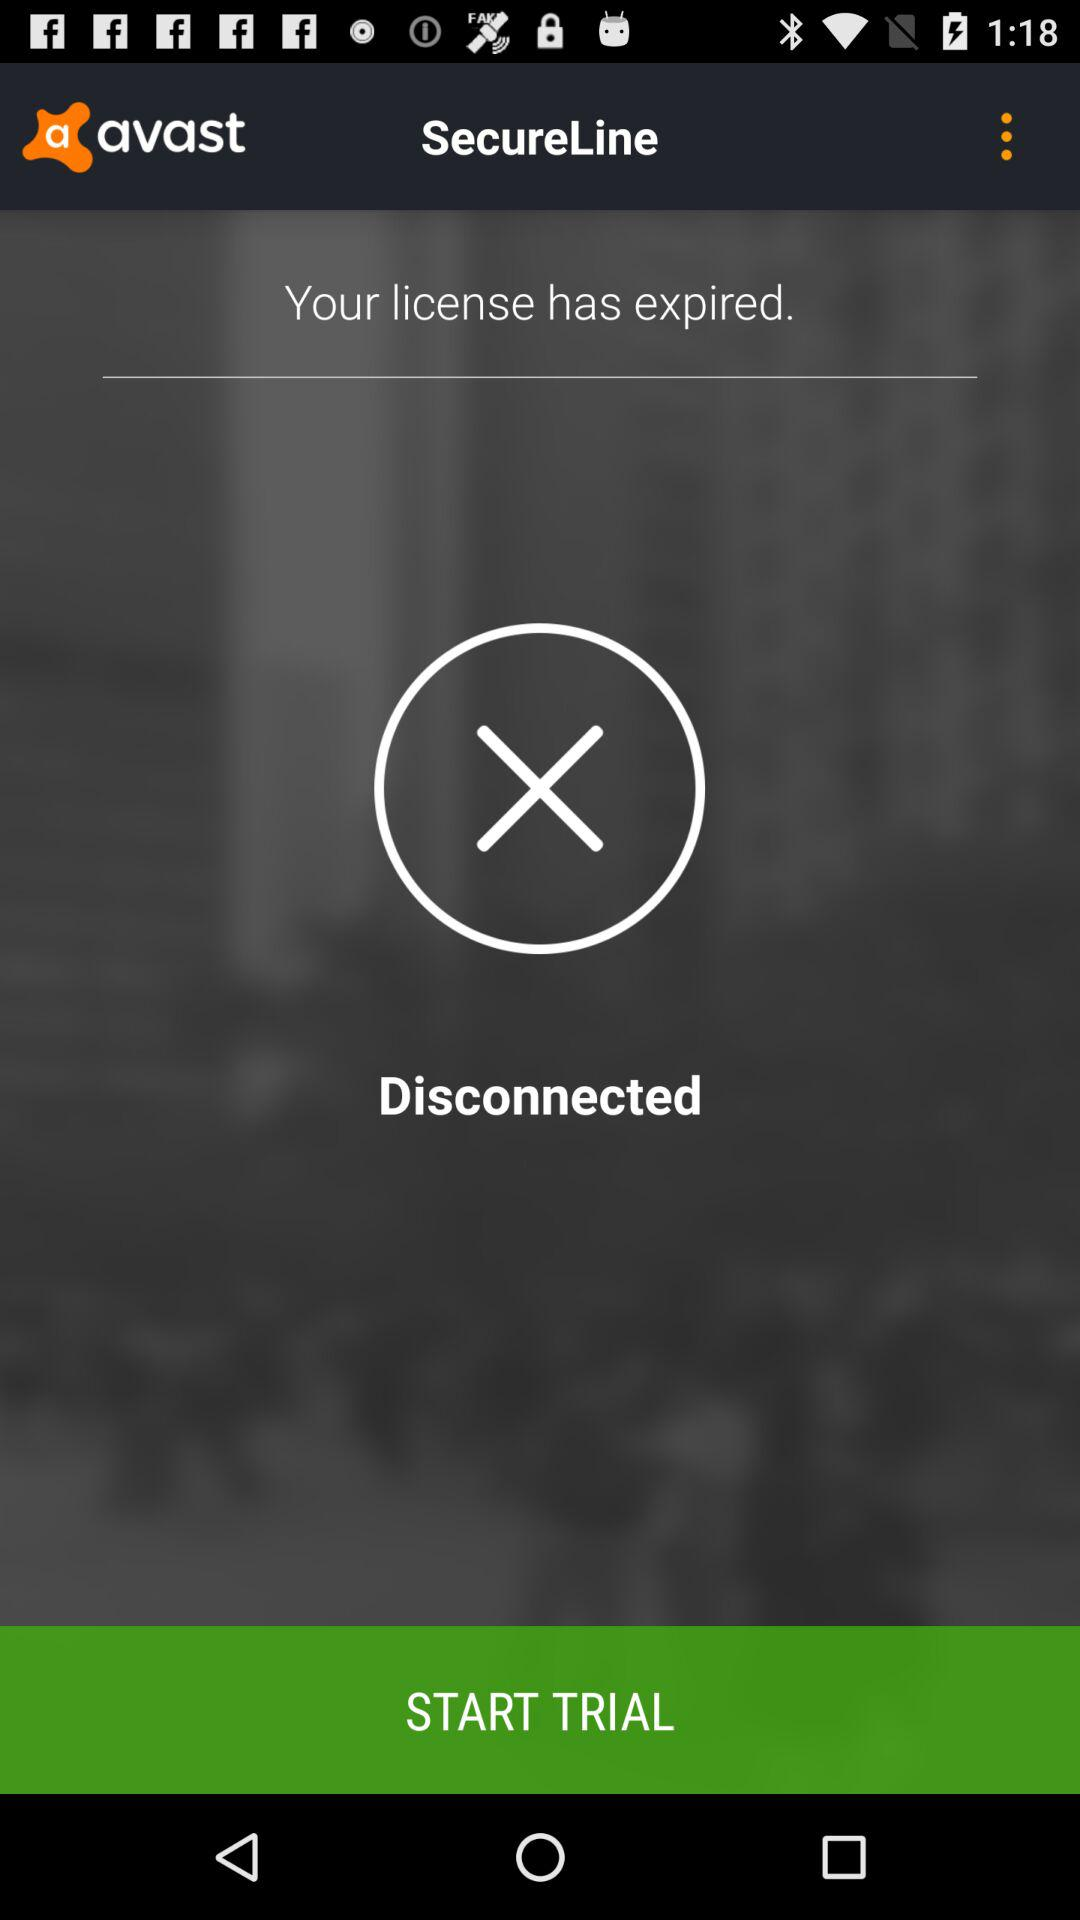What is the user's license number?
When the provided information is insufficient, respond with <no answer>. <no answer> 